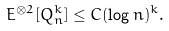<formula> <loc_0><loc_0><loc_500><loc_500>E ^ { \otimes 2 } [ Q _ { n } ^ { k } ] \leq C ( \log n ) ^ { k } .</formula> 